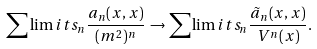Convert formula to latex. <formula><loc_0><loc_0><loc_500><loc_500>\sum \lim i t s _ { n } \frac { a _ { n } ( x , x ) } { ( m ^ { 2 } ) ^ { n } } \, \rightarrow \sum \lim i t s _ { n } \frac { \tilde { a } _ { n } ( x , x ) } { V ^ { n } ( x ) } .</formula> 